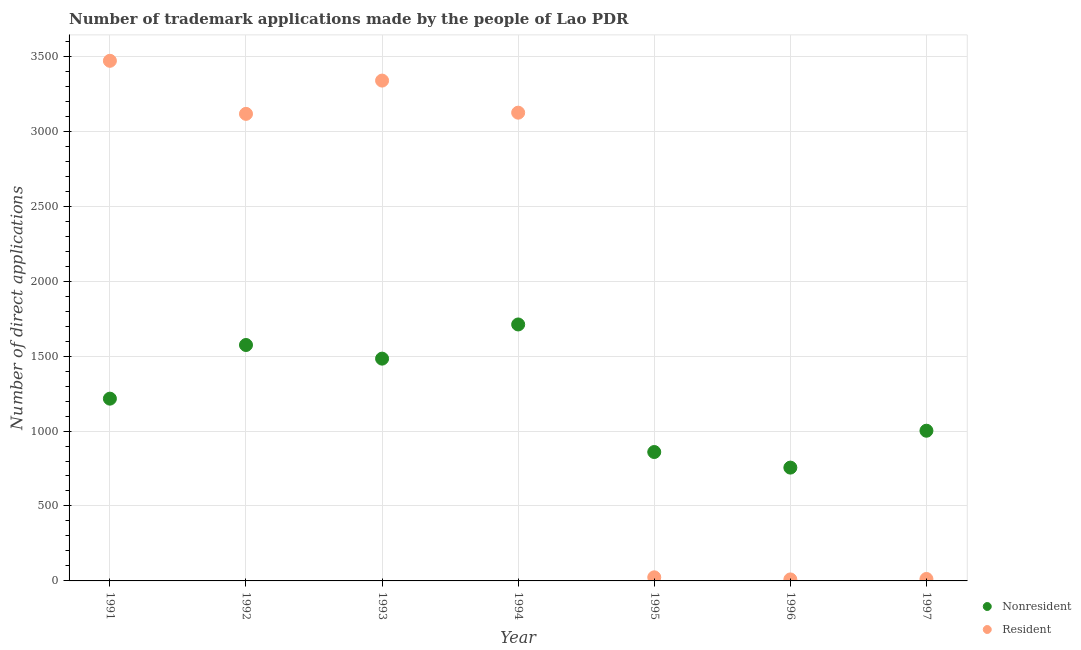What is the number of trademark applications made by residents in 1995?
Offer a terse response. 24. Across all years, what is the maximum number of trademark applications made by residents?
Provide a succinct answer. 3470. Across all years, what is the minimum number of trademark applications made by non residents?
Ensure brevity in your answer.  756. What is the total number of trademark applications made by residents in the graph?
Your answer should be compact. 1.31e+04. What is the difference between the number of trademark applications made by non residents in 1991 and that in 1993?
Make the answer very short. -267. What is the difference between the number of trademark applications made by residents in 1993 and the number of trademark applications made by non residents in 1991?
Provide a succinct answer. 2122. What is the average number of trademark applications made by non residents per year?
Provide a succinct answer. 1228.86. In the year 1994, what is the difference between the number of trademark applications made by non residents and number of trademark applications made by residents?
Ensure brevity in your answer.  -1413. In how many years, is the number of trademark applications made by residents greater than 600?
Keep it short and to the point. 4. What is the ratio of the number of trademark applications made by non residents in 1992 to that in 1994?
Make the answer very short. 0.92. What is the difference between the highest and the second highest number of trademark applications made by residents?
Make the answer very short. 132. What is the difference between the highest and the lowest number of trademark applications made by non residents?
Make the answer very short. 955. In how many years, is the number of trademark applications made by non residents greater than the average number of trademark applications made by non residents taken over all years?
Give a very brief answer. 3. Is the sum of the number of trademark applications made by residents in 1991 and 1996 greater than the maximum number of trademark applications made by non residents across all years?
Give a very brief answer. Yes. Is the number of trademark applications made by residents strictly less than the number of trademark applications made by non residents over the years?
Your answer should be very brief. No. How many years are there in the graph?
Your answer should be very brief. 7. What is the difference between two consecutive major ticks on the Y-axis?
Offer a very short reply. 500. Does the graph contain any zero values?
Ensure brevity in your answer.  No. Where does the legend appear in the graph?
Provide a short and direct response. Bottom right. How many legend labels are there?
Ensure brevity in your answer.  2. How are the legend labels stacked?
Your answer should be compact. Vertical. What is the title of the graph?
Your response must be concise. Number of trademark applications made by the people of Lao PDR. What is the label or title of the X-axis?
Give a very brief answer. Year. What is the label or title of the Y-axis?
Keep it short and to the point. Number of direct applications. What is the Number of direct applications in Nonresident in 1991?
Your answer should be compact. 1216. What is the Number of direct applications of Resident in 1991?
Your answer should be very brief. 3470. What is the Number of direct applications of Nonresident in 1992?
Provide a short and direct response. 1574. What is the Number of direct applications in Resident in 1992?
Provide a succinct answer. 3116. What is the Number of direct applications of Nonresident in 1993?
Your answer should be compact. 1483. What is the Number of direct applications of Resident in 1993?
Offer a very short reply. 3338. What is the Number of direct applications in Nonresident in 1994?
Your answer should be compact. 1711. What is the Number of direct applications in Resident in 1994?
Give a very brief answer. 3124. What is the Number of direct applications in Nonresident in 1995?
Keep it short and to the point. 860. What is the Number of direct applications of Nonresident in 1996?
Your answer should be very brief. 756. What is the Number of direct applications of Nonresident in 1997?
Provide a short and direct response. 1002. What is the Number of direct applications in Resident in 1997?
Provide a succinct answer. 13. Across all years, what is the maximum Number of direct applications of Nonresident?
Provide a short and direct response. 1711. Across all years, what is the maximum Number of direct applications in Resident?
Your response must be concise. 3470. Across all years, what is the minimum Number of direct applications in Nonresident?
Offer a very short reply. 756. What is the total Number of direct applications in Nonresident in the graph?
Offer a very short reply. 8602. What is the total Number of direct applications of Resident in the graph?
Give a very brief answer. 1.31e+04. What is the difference between the Number of direct applications in Nonresident in 1991 and that in 1992?
Make the answer very short. -358. What is the difference between the Number of direct applications in Resident in 1991 and that in 1992?
Keep it short and to the point. 354. What is the difference between the Number of direct applications of Nonresident in 1991 and that in 1993?
Make the answer very short. -267. What is the difference between the Number of direct applications of Resident in 1991 and that in 1993?
Ensure brevity in your answer.  132. What is the difference between the Number of direct applications in Nonresident in 1991 and that in 1994?
Provide a succinct answer. -495. What is the difference between the Number of direct applications in Resident in 1991 and that in 1994?
Make the answer very short. 346. What is the difference between the Number of direct applications of Nonresident in 1991 and that in 1995?
Provide a succinct answer. 356. What is the difference between the Number of direct applications of Resident in 1991 and that in 1995?
Offer a terse response. 3446. What is the difference between the Number of direct applications in Nonresident in 1991 and that in 1996?
Your answer should be compact. 460. What is the difference between the Number of direct applications of Resident in 1991 and that in 1996?
Offer a terse response. 3460. What is the difference between the Number of direct applications of Nonresident in 1991 and that in 1997?
Offer a very short reply. 214. What is the difference between the Number of direct applications of Resident in 1991 and that in 1997?
Keep it short and to the point. 3457. What is the difference between the Number of direct applications in Nonresident in 1992 and that in 1993?
Provide a short and direct response. 91. What is the difference between the Number of direct applications of Resident in 1992 and that in 1993?
Offer a very short reply. -222. What is the difference between the Number of direct applications in Nonresident in 1992 and that in 1994?
Make the answer very short. -137. What is the difference between the Number of direct applications of Resident in 1992 and that in 1994?
Provide a short and direct response. -8. What is the difference between the Number of direct applications of Nonresident in 1992 and that in 1995?
Give a very brief answer. 714. What is the difference between the Number of direct applications in Resident in 1992 and that in 1995?
Provide a succinct answer. 3092. What is the difference between the Number of direct applications of Nonresident in 1992 and that in 1996?
Keep it short and to the point. 818. What is the difference between the Number of direct applications of Resident in 1992 and that in 1996?
Ensure brevity in your answer.  3106. What is the difference between the Number of direct applications of Nonresident in 1992 and that in 1997?
Provide a short and direct response. 572. What is the difference between the Number of direct applications of Resident in 1992 and that in 1997?
Ensure brevity in your answer.  3103. What is the difference between the Number of direct applications of Nonresident in 1993 and that in 1994?
Give a very brief answer. -228. What is the difference between the Number of direct applications in Resident in 1993 and that in 1994?
Your response must be concise. 214. What is the difference between the Number of direct applications in Nonresident in 1993 and that in 1995?
Give a very brief answer. 623. What is the difference between the Number of direct applications of Resident in 1993 and that in 1995?
Provide a succinct answer. 3314. What is the difference between the Number of direct applications in Nonresident in 1993 and that in 1996?
Offer a very short reply. 727. What is the difference between the Number of direct applications in Resident in 1993 and that in 1996?
Your response must be concise. 3328. What is the difference between the Number of direct applications in Nonresident in 1993 and that in 1997?
Your response must be concise. 481. What is the difference between the Number of direct applications of Resident in 1993 and that in 1997?
Your answer should be very brief. 3325. What is the difference between the Number of direct applications in Nonresident in 1994 and that in 1995?
Your response must be concise. 851. What is the difference between the Number of direct applications of Resident in 1994 and that in 1995?
Offer a very short reply. 3100. What is the difference between the Number of direct applications of Nonresident in 1994 and that in 1996?
Your answer should be compact. 955. What is the difference between the Number of direct applications in Resident in 1994 and that in 1996?
Provide a short and direct response. 3114. What is the difference between the Number of direct applications of Nonresident in 1994 and that in 1997?
Provide a short and direct response. 709. What is the difference between the Number of direct applications in Resident in 1994 and that in 1997?
Offer a very short reply. 3111. What is the difference between the Number of direct applications of Nonresident in 1995 and that in 1996?
Your answer should be compact. 104. What is the difference between the Number of direct applications in Nonresident in 1995 and that in 1997?
Provide a succinct answer. -142. What is the difference between the Number of direct applications in Resident in 1995 and that in 1997?
Offer a very short reply. 11. What is the difference between the Number of direct applications in Nonresident in 1996 and that in 1997?
Your response must be concise. -246. What is the difference between the Number of direct applications of Nonresident in 1991 and the Number of direct applications of Resident in 1992?
Keep it short and to the point. -1900. What is the difference between the Number of direct applications of Nonresident in 1991 and the Number of direct applications of Resident in 1993?
Ensure brevity in your answer.  -2122. What is the difference between the Number of direct applications in Nonresident in 1991 and the Number of direct applications in Resident in 1994?
Make the answer very short. -1908. What is the difference between the Number of direct applications of Nonresident in 1991 and the Number of direct applications of Resident in 1995?
Your response must be concise. 1192. What is the difference between the Number of direct applications in Nonresident in 1991 and the Number of direct applications in Resident in 1996?
Provide a succinct answer. 1206. What is the difference between the Number of direct applications of Nonresident in 1991 and the Number of direct applications of Resident in 1997?
Ensure brevity in your answer.  1203. What is the difference between the Number of direct applications in Nonresident in 1992 and the Number of direct applications in Resident in 1993?
Provide a short and direct response. -1764. What is the difference between the Number of direct applications in Nonresident in 1992 and the Number of direct applications in Resident in 1994?
Provide a short and direct response. -1550. What is the difference between the Number of direct applications in Nonresident in 1992 and the Number of direct applications in Resident in 1995?
Give a very brief answer. 1550. What is the difference between the Number of direct applications of Nonresident in 1992 and the Number of direct applications of Resident in 1996?
Provide a succinct answer. 1564. What is the difference between the Number of direct applications in Nonresident in 1992 and the Number of direct applications in Resident in 1997?
Your response must be concise. 1561. What is the difference between the Number of direct applications in Nonresident in 1993 and the Number of direct applications in Resident in 1994?
Your answer should be very brief. -1641. What is the difference between the Number of direct applications of Nonresident in 1993 and the Number of direct applications of Resident in 1995?
Ensure brevity in your answer.  1459. What is the difference between the Number of direct applications of Nonresident in 1993 and the Number of direct applications of Resident in 1996?
Offer a very short reply. 1473. What is the difference between the Number of direct applications in Nonresident in 1993 and the Number of direct applications in Resident in 1997?
Your answer should be very brief. 1470. What is the difference between the Number of direct applications of Nonresident in 1994 and the Number of direct applications of Resident in 1995?
Your response must be concise. 1687. What is the difference between the Number of direct applications of Nonresident in 1994 and the Number of direct applications of Resident in 1996?
Your response must be concise. 1701. What is the difference between the Number of direct applications in Nonresident in 1994 and the Number of direct applications in Resident in 1997?
Offer a very short reply. 1698. What is the difference between the Number of direct applications in Nonresident in 1995 and the Number of direct applications in Resident in 1996?
Provide a short and direct response. 850. What is the difference between the Number of direct applications in Nonresident in 1995 and the Number of direct applications in Resident in 1997?
Make the answer very short. 847. What is the difference between the Number of direct applications of Nonresident in 1996 and the Number of direct applications of Resident in 1997?
Give a very brief answer. 743. What is the average Number of direct applications of Nonresident per year?
Your response must be concise. 1228.86. What is the average Number of direct applications of Resident per year?
Your answer should be very brief. 1870.71. In the year 1991, what is the difference between the Number of direct applications in Nonresident and Number of direct applications in Resident?
Offer a terse response. -2254. In the year 1992, what is the difference between the Number of direct applications in Nonresident and Number of direct applications in Resident?
Provide a short and direct response. -1542. In the year 1993, what is the difference between the Number of direct applications of Nonresident and Number of direct applications of Resident?
Your answer should be very brief. -1855. In the year 1994, what is the difference between the Number of direct applications in Nonresident and Number of direct applications in Resident?
Offer a very short reply. -1413. In the year 1995, what is the difference between the Number of direct applications of Nonresident and Number of direct applications of Resident?
Offer a very short reply. 836. In the year 1996, what is the difference between the Number of direct applications in Nonresident and Number of direct applications in Resident?
Your answer should be compact. 746. In the year 1997, what is the difference between the Number of direct applications in Nonresident and Number of direct applications in Resident?
Make the answer very short. 989. What is the ratio of the Number of direct applications of Nonresident in 1991 to that in 1992?
Your answer should be compact. 0.77. What is the ratio of the Number of direct applications of Resident in 1991 to that in 1992?
Your response must be concise. 1.11. What is the ratio of the Number of direct applications of Nonresident in 1991 to that in 1993?
Offer a terse response. 0.82. What is the ratio of the Number of direct applications in Resident in 1991 to that in 1993?
Keep it short and to the point. 1.04. What is the ratio of the Number of direct applications of Nonresident in 1991 to that in 1994?
Offer a very short reply. 0.71. What is the ratio of the Number of direct applications in Resident in 1991 to that in 1994?
Provide a short and direct response. 1.11. What is the ratio of the Number of direct applications in Nonresident in 1991 to that in 1995?
Make the answer very short. 1.41. What is the ratio of the Number of direct applications of Resident in 1991 to that in 1995?
Your response must be concise. 144.58. What is the ratio of the Number of direct applications in Nonresident in 1991 to that in 1996?
Ensure brevity in your answer.  1.61. What is the ratio of the Number of direct applications in Resident in 1991 to that in 1996?
Give a very brief answer. 347. What is the ratio of the Number of direct applications in Nonresident in 1991 to that in 1997?
Offer a terse response. 1.21. What is the ratio of the Number of direct applications of Resident in 1991 to that in 1997?
Offer a very short reply. 266.92. What is the ratio of the Number of direct applications in Nonresident in 1992 to that in 1993?
Your answer should be very brief. 1.06. What is the ratio of the Number of direct applications in Resident in 1992 to that in 1993?
Your response must be concise. 0.93. What is the ratio of the Number of direct applications of Nonresident in 1992 to that in 1994?
Provide a short and direct response. 0.92. What is the ratio of the Number of direct applications in Resident in 1992 to that in 1994?
Your answer should be compact. 1. What is the ratio of the Number of direct applications in Nonresident in 1992 to that in 1995?
Offer a very short reply. 1.83. What is the ratio of the Number of direct applications in Resident in 1992 to that in 1995?
Give a very brief answer. 129.83. What is the ratio of the Number of direct applications in Nonresident in 1992 to that in 1996?
Your answer should be compact. 2.08. What is the ratio of the Number of direct applications in Resident in 1992 to that in 1996?
Your answer should be compact. 311.6. What is the ratio of the Number of direct applications in Nonresident in 1992 to that in 1997?
Provide a succinct answer. 1.57. What is the ratio of the Number of direct applications in Resident in 1992 to that in 1997?
Give a very brief answer. 239.69. What is the ratio of the Number of direct applications in Nonresident in 1993 to that in 1994?
Provide a short and direct response. 0.87. What is the ratio of the Number of direct applications in Resident in 1993 to that in 1994?
Ensure brevity in your answer.  1.07. What is the ratio of the Number of direct applications of Nonresident in 1993 to that in 1995?
Offer a very short reply. 1.72. What is the ratio of the Number of direct applications of Resident in 1993 to that in 1995?
Your response must be concise. 139.08. What is the ratio of the Number of direct applications of Nonresident in 1993 to that in 1996?
Your answer should be very brief. 1.96. What is the ratio of the Number of direct applications of Resident in 1993 to that in 1996?
Offer a very short reply. 333.8. What is the ratio of the Number of direct applications of Nonresident in 1993 to that in 1997?
Your response must be concise. 1.48. What is the ratio of the Number of direct applications of Resident in 1993 to that in 1997?
Keep it short and to the point. 256.77. What is the ratio of the Number of direct applications of Nonresident in 1994 to that in 1995?
Offer a terse response. 1.99. What is the ratio of the Number of direct applications in Resident in 1994 to that in 1995?
Make the answer very short. 130.17. What is the ratio of the Number of direct applications of Nonresident in 1994 to that in 1996?
Your answer should be very brief. 2.26. What is the ratio of the Number of direct applications in Resident in 1994 to that in 1996?
Ensure brevity in your answer.  312.4. What is the ratio of the Number of direct applications in Nonresident in 1994 to that in 1997?
Provide a succinct answer. 1.71. What is the ratio of the Number of direct applications in Resident in 1994 to that in 1997?
Your answer should be compact. 240.31. What is the ratio of the Number of direct applications in Nonresident in 1995 to that in 1996?
Your answer should be very brief. 1.14. What is the ratio of the Number of direct applications of Nonresident in 1995 to that in 1997?
Your answer should be very brief. 0.86. What is the ratio of the Number of direct applications in Resident in 1995 to that in 1997?
Ensure brevity in your answer.  1.85. What is the ratio of the Number of direct applications in Nonresident in 1996 to that in 1997?
Your answer should be compact. 0.75. What is the ratio of the Number of direct applications in Resident in 1996 to that in 1997?
Offer a terse response. 0.77. What is the difference between the highest and the second highest Number of direct applications in Nonresident?
Provide a succinct answer. 137. What is the difference between the highest and the second highest Number of direct applications in Resident?
Offer a terse response. 132. What is the difference between the highest and the lowest Number of direct applications in Nonresident?
Offer a very short reply. 955. What is the difference between the highest and the lowest Number of direct applications in Resident?
Offer a terse response. 3460. 